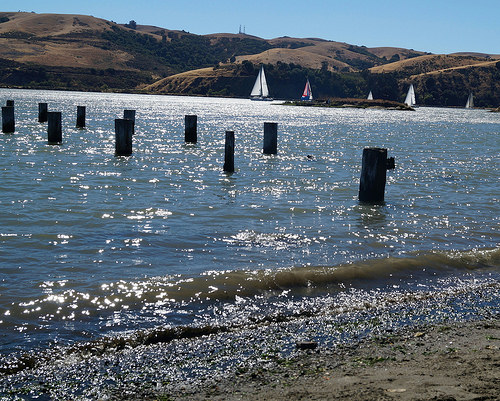<image>
Can you confirm if the pole is on the water? Yes. Looking at the image, I can see the pole is positioned on top of the water, with the water providing support. 